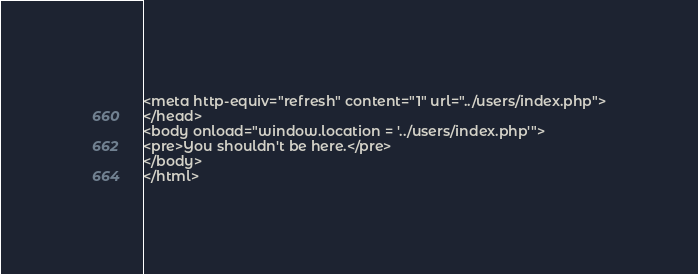<code> <loc_0><loc_0><loc_500><loc_500><_PHP_><meta http-equiv="refresh" content="1" url="../users/index.php">
</head>
<body onload="window.location = '../users/index.php'">
<pre>You shouldn't be here.</pre>
</body>
</html>
</code> 